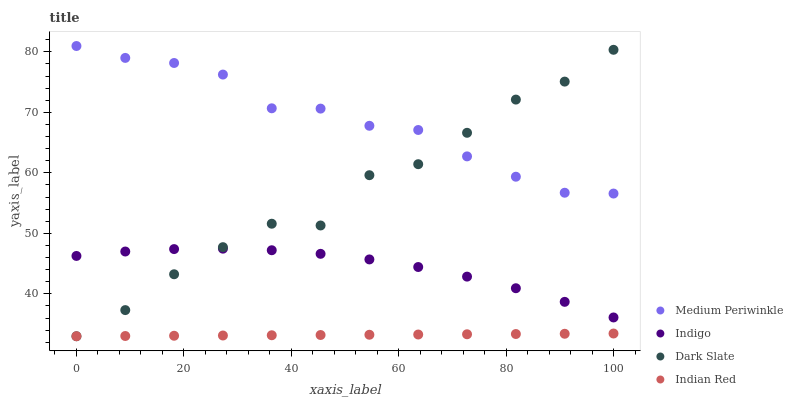Does Indian Red have the minimum area under the curve?
Answer yes or no. Yes. Does Medium Periwinkle have the maximum area under the curve?
Answer yes or no. Yes. Does Medium Periwinkle have the minimum area under the curve?
Answer yes or no. No. Does Indian Red have the maximum area under the curve?
Answer yes or no. No. Is Indian Red the smoothest?
Answer yes or no. Yes. Is Dark Slate the roughest?
Answer yes or no. Yes. Is Medium Periwinkle the smoothest?
Answer yes or no. No. Is Medium Periwinkle the roughest?
Answer yes or no. No. Does Indian Red have the lowest value?
Answer yes or no. Yes. Does Medium Periwinkle have the lowest value?
Answer yes or no. No. Does Medium Periwinkle have the highest value?
Answer yes or no. Yes. Does Indian Red have the highest value?
Answer yes or no. No. Is Indigo less than Medium Periwinkle?
Answer yes or no. Yes. Is Medium Periwinkle greater than Indigo?
Answer yes or no. Yes. Does Indian Red intersect Dark Slate?
Answer yes or no. Yes. Is Indian Red less than Dark Slate?
Answer yes or no. No. Is Indian Red greater than Dark Slate?
Answer yes or no. No. Does Indigo intersect Medium Periwinkle?
Answer yes or no. No. 